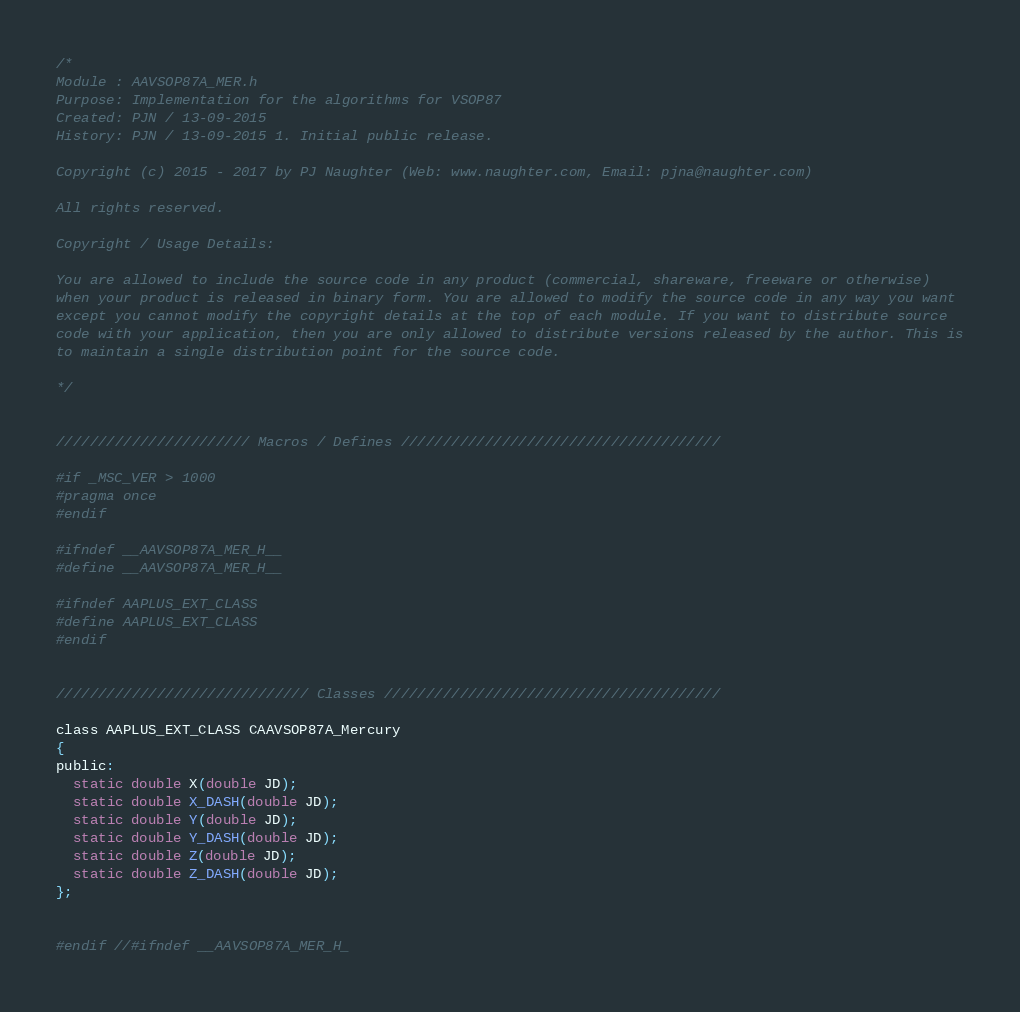<code> <loc_0><loc_0><loc_500><loc_500><_C_>/*
Module : AAVSOP87A_MER.h
Purpose: Implementation for the algorithms for VSOP87
Created: PJN / 13-09-2015
History: PJN / 13-09-2015 1. Initial public release.

Copyright (c) 2015 - 2017 by PJ Naughter (Web: www.naughter.com, Email: pjna@naughter.com)

All rights reserved.

Copyright / Usage Details:

You are allowed to include the source code in any product (commercial, shareware, freeware or otherwise)
when your product is released in binary form. You are allowed to modify the source code in any way you want
except you cannot modify the copyright details at the top of each module. If you want to distribute source
code with your application, then you are only allowed to distribute versions released by the author. This is
to maintain a single distribution point for the source code.

*/


/////////////////////// Macros / Defines //////////////////////////////////////

#if _MSC_VER > 1000
#pragma once
#endif

#ifndef __AAVSOP87A_MER_H__
#define __AAVSOP87A_MER_H__

#ifndef AAPLUS_EXT_CLASS
#define AAPLUS_EXT_CLASS
#endif


////////////////////////////// Classes ////////////////////////////////////////

class AAPLUS_EXT_CLASS CAAVSOP87A_Mercury
{
public:
  static double X(double JD);
  static double X_DASH(double JD);
  static double Y(double JD);
  static double Y_DASH(double JD);
  static double Z(double JD);
  static double Z_DASH(double JD);
};


#endif //#ifndef __AAVSOP87A_MER_H_
</code> 